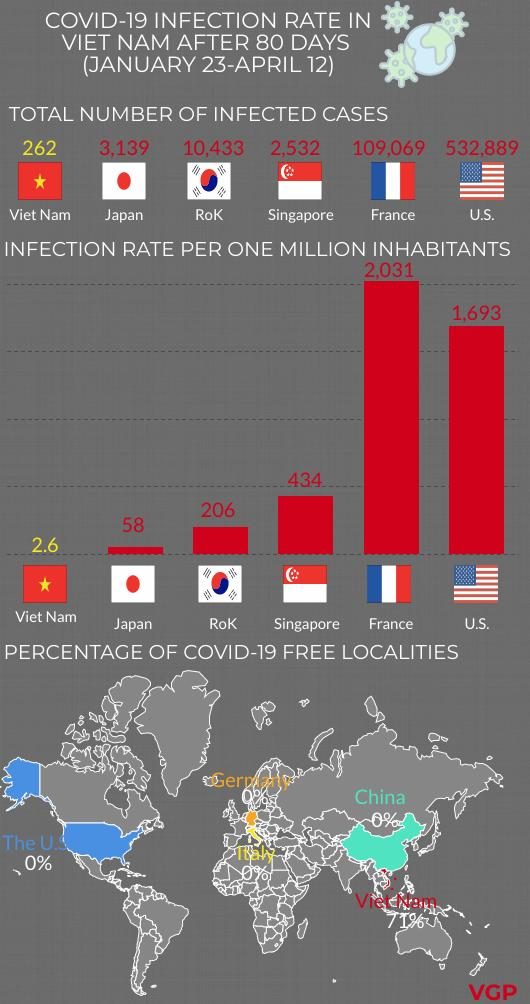Specify some key components in this picture. Japan has the second lowest total number of infected cases among all countries. Six countries' flags are displayed. France has a higher number of infected cases than Singapore, with 1,06,537 cases compared to Singapore's 37,060 cases. The countries of Viet Nam, Japan, and the Republic of Korea have infection rates below 400. 